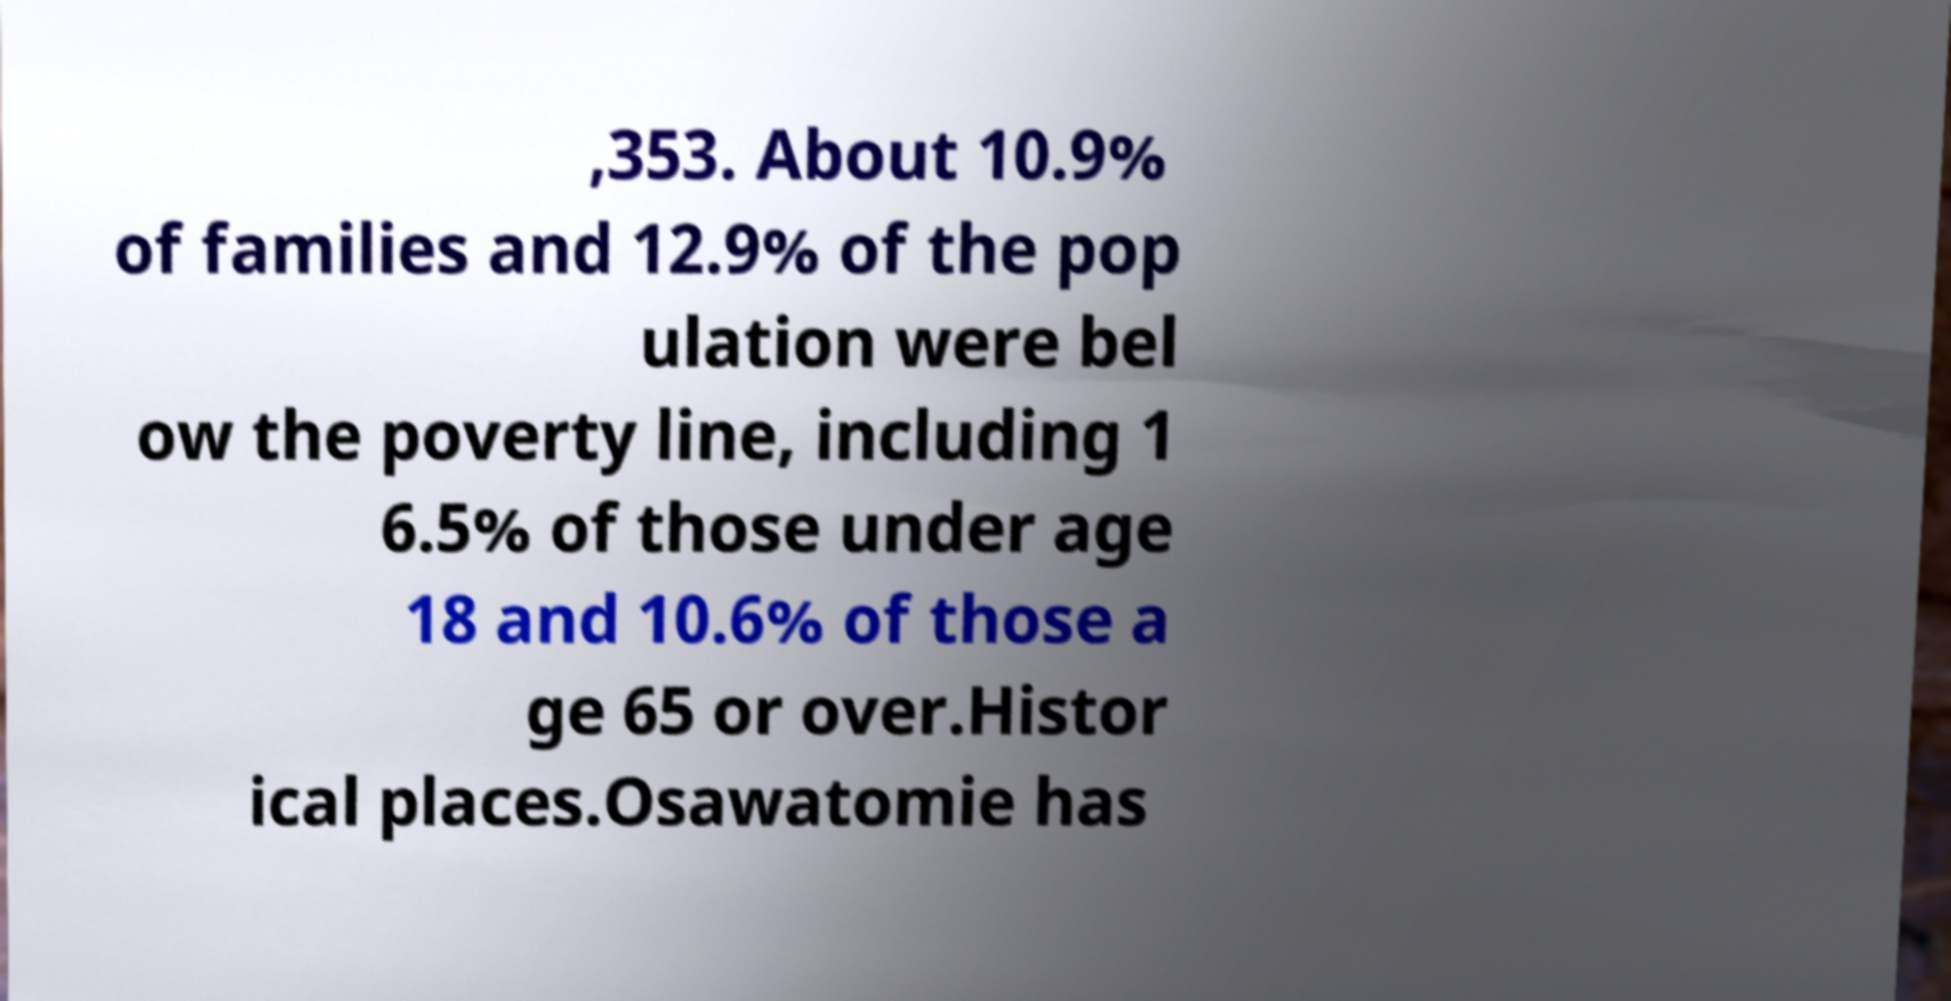There's text embedded in this image that I need extracted. Can you transcribe it verbatim? ,353. About 10.9% of families and 12.9% of the pop ulation were bel ow the poverty line, including 1 6.5% of those under age 18 and 10.6% of those a ge 65 or over.Histor ical places.Osawatomie has 